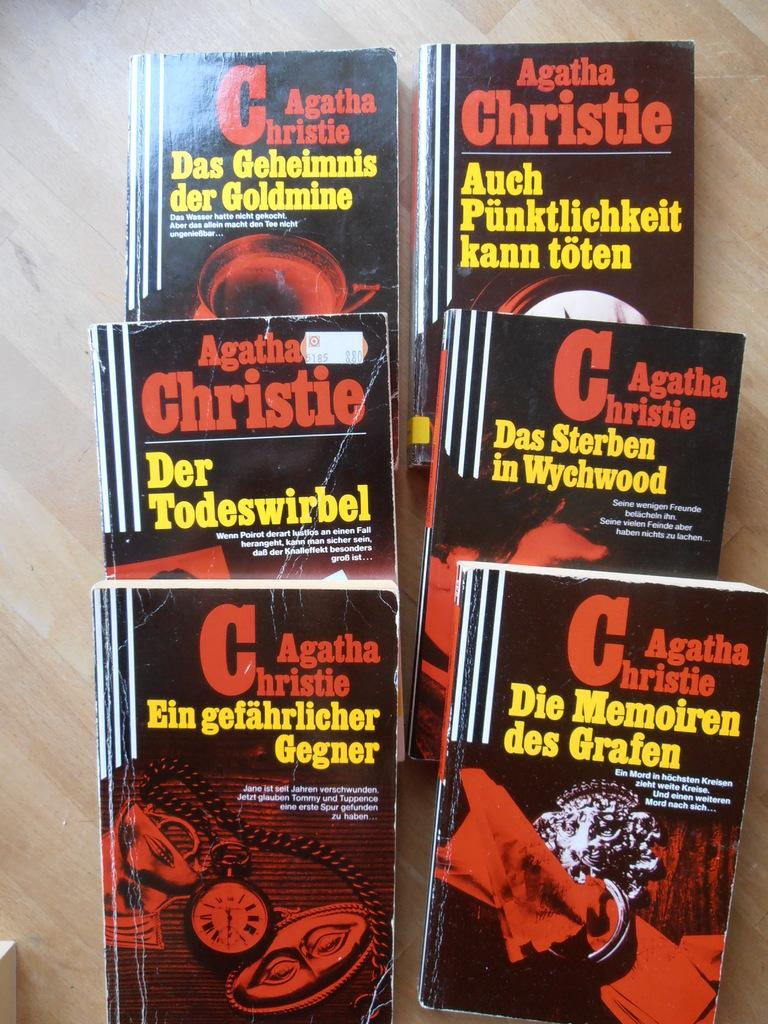<image>
Create a compact narrative representing the image presented. six agatha christie books are laying out on a table 